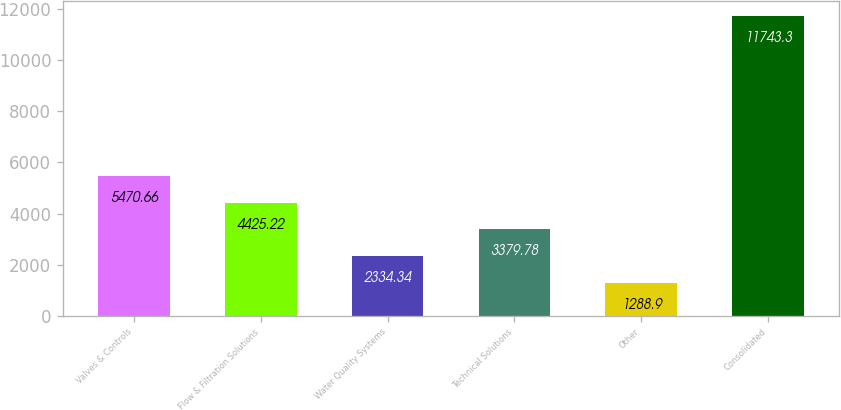Convert chart. <chart><loc_0><loc_0><loc_500><loc_500><bar_chart><fcel>Valves & Controls<fcel>Flow & Filtration Solutions<fcel>Water Quality Systems<fcel>Technical Solutions<fcel>Other<fcel>Consolidated<nl><fcel>5470.66<fcel>4425.22<fcel>2334.34<fcel>3379.78<fcel>1288.9<fcel>11743.3<nl></chart> 